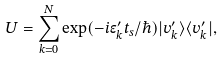Convert formula to latex. <formula><loc_0><loc_0><loc_500><loc_500>U = \sum _ { k = 0 } ^ { N } \exp ( - i \epsilon _ { k } ^ { \prime } t _ { s } / \hbar { ) } | v _ { k } ^ { \prime } \rangle \langle v _ { k } ^ { \prime } | ,</formula> 